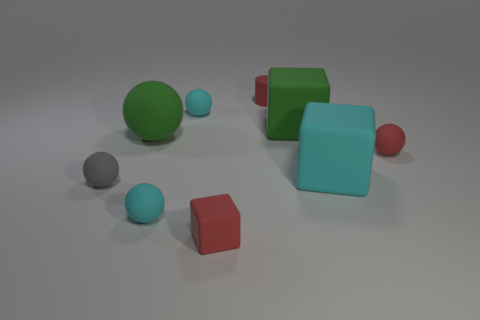Can you describe how lighting appears to affect the scene? Certainly! The lighting in the scene creates a soft and diffuse atmosphere, with shadows gently cast to the right of the objects. This suggests a light source positioned to the left and above the arrangement, providing a gentle illumination that highlights the shapes and colors of the assorted objects. 